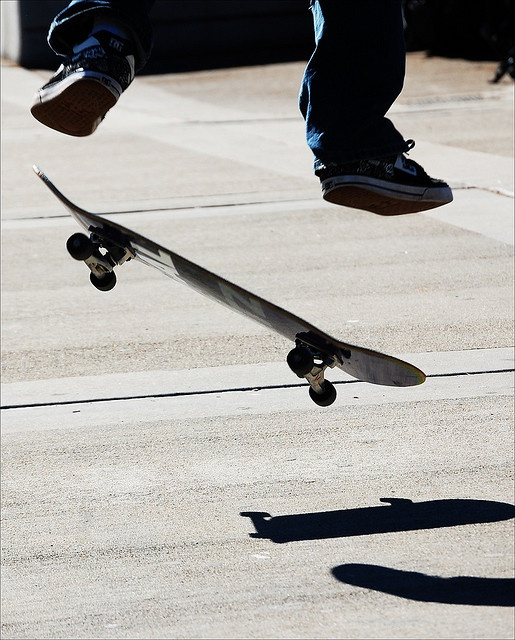Describe the objects in this image and their specific colors. I can see people in gray, black, lightgray, and navy tones and skateboard in gray, black, darkgray, and lightgray tones in this image. 